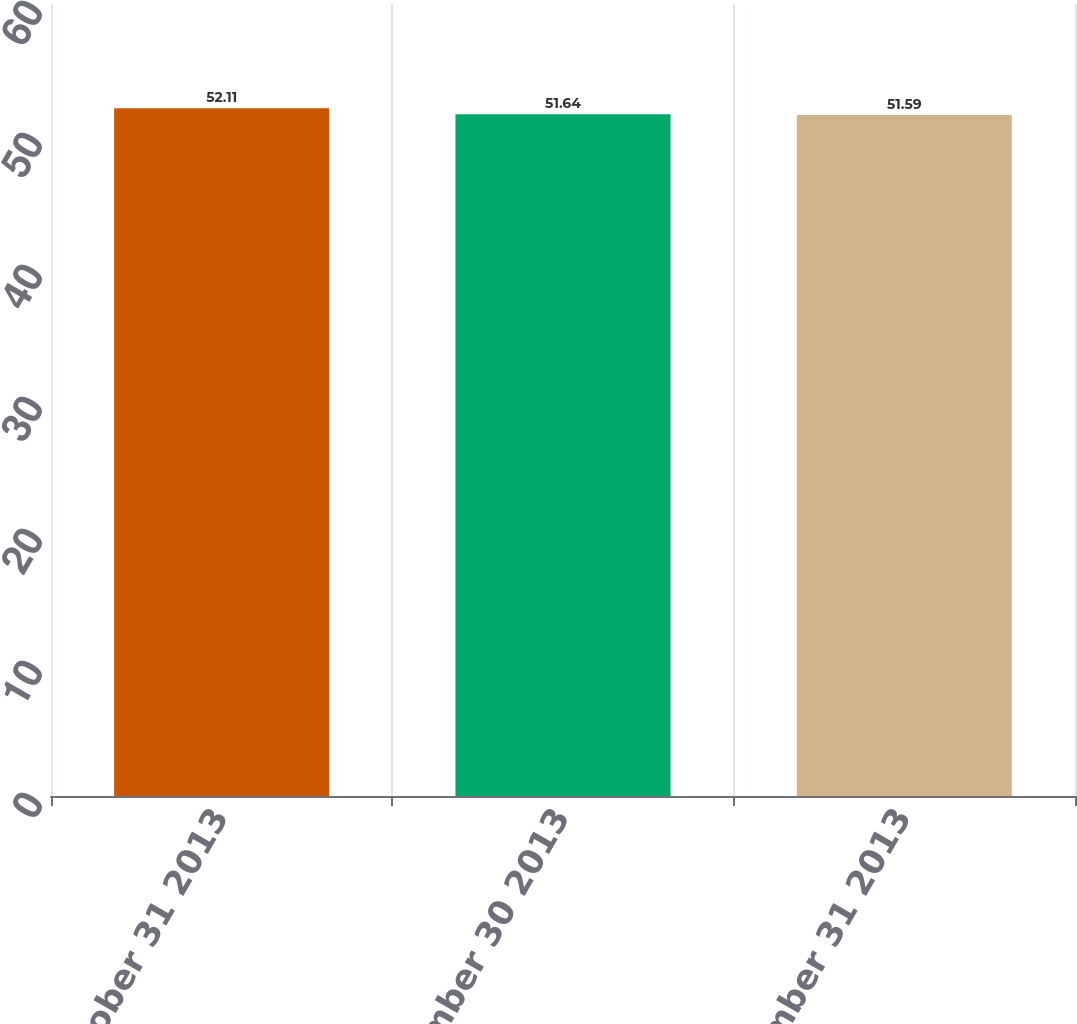Convert chart to OTSL. <chart><loc_0><loc_0><loc_500><loc_500><bar_chart><fcel>October 31 2013<fcel>November 30 2013<fcel>December 31 2013<nl><fcel>52.11<fcel>51.64<fcel>51.59<nl></chart> 